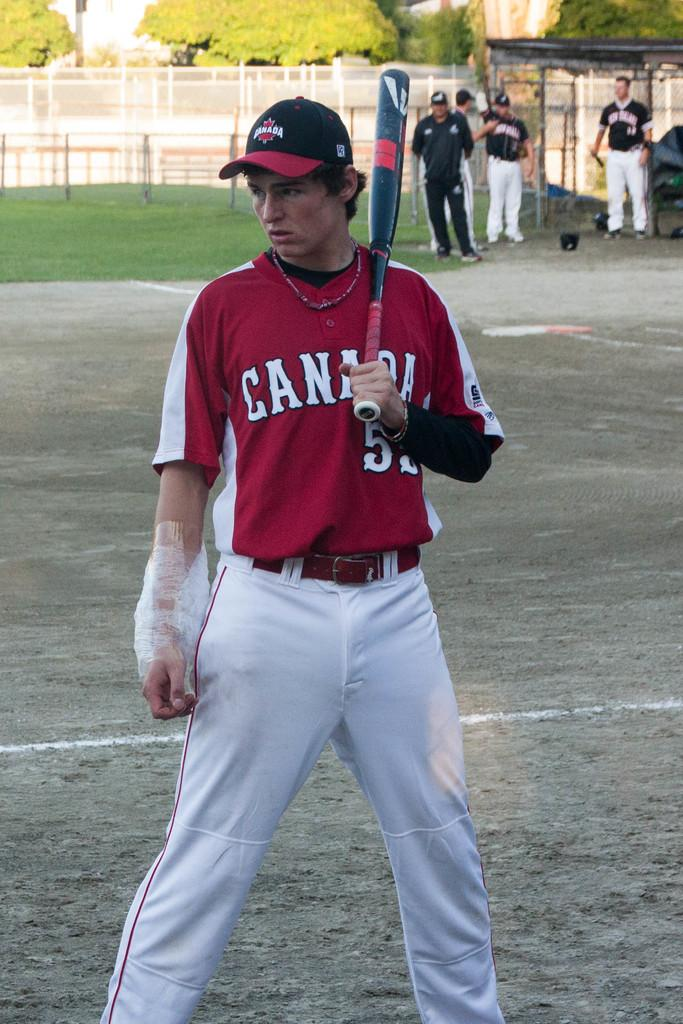<image>
Render a clear and concise summary of the photo. a baseball player from team canada holding a bat 